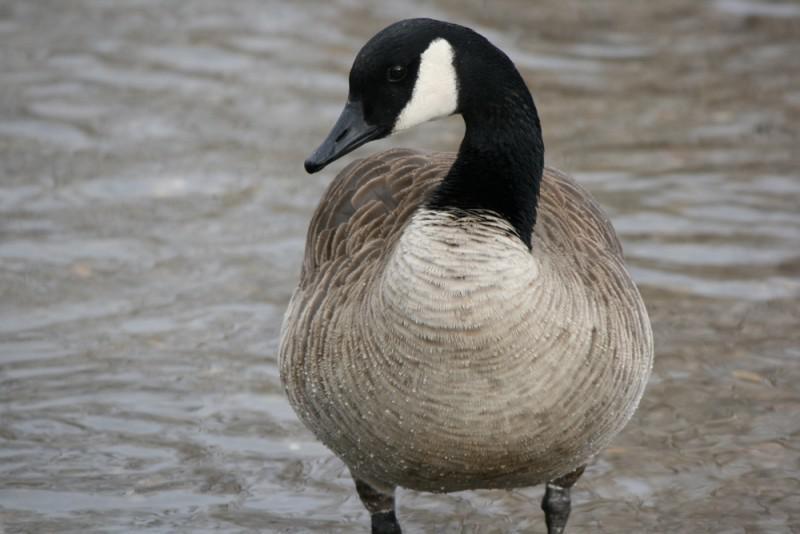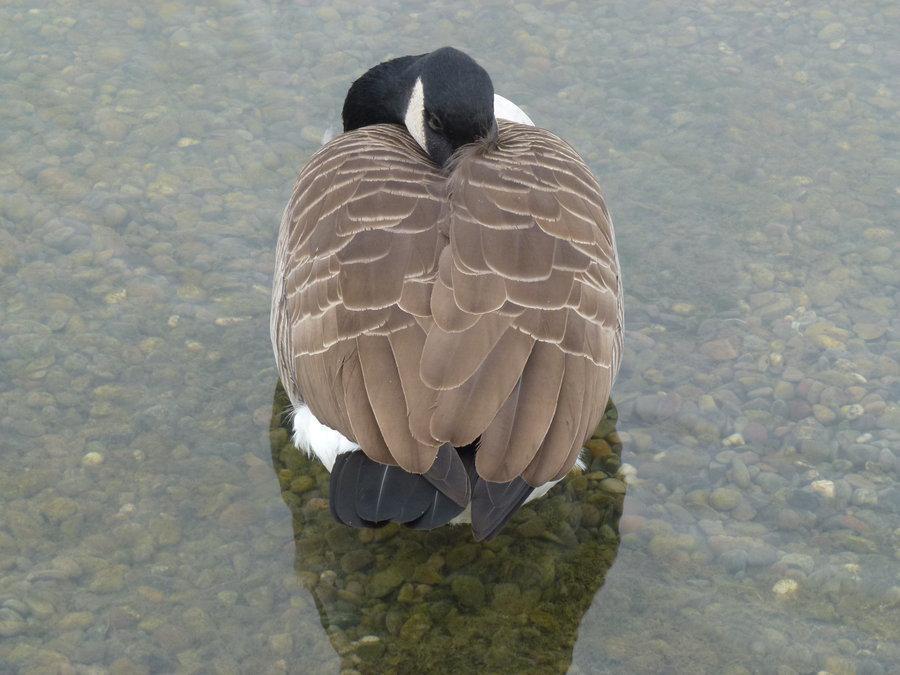The first image is the image on the left, the second image is the image on the right. Considering the images on both sides, is "An image shows one bird in the water, with its neck turned backward." valid? Answer yes or no. Yes. 